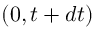Convert formula to latex. <formula><loc_0><loc_0><loc_500><loc_500>( 0 , t + d t )</formula> 